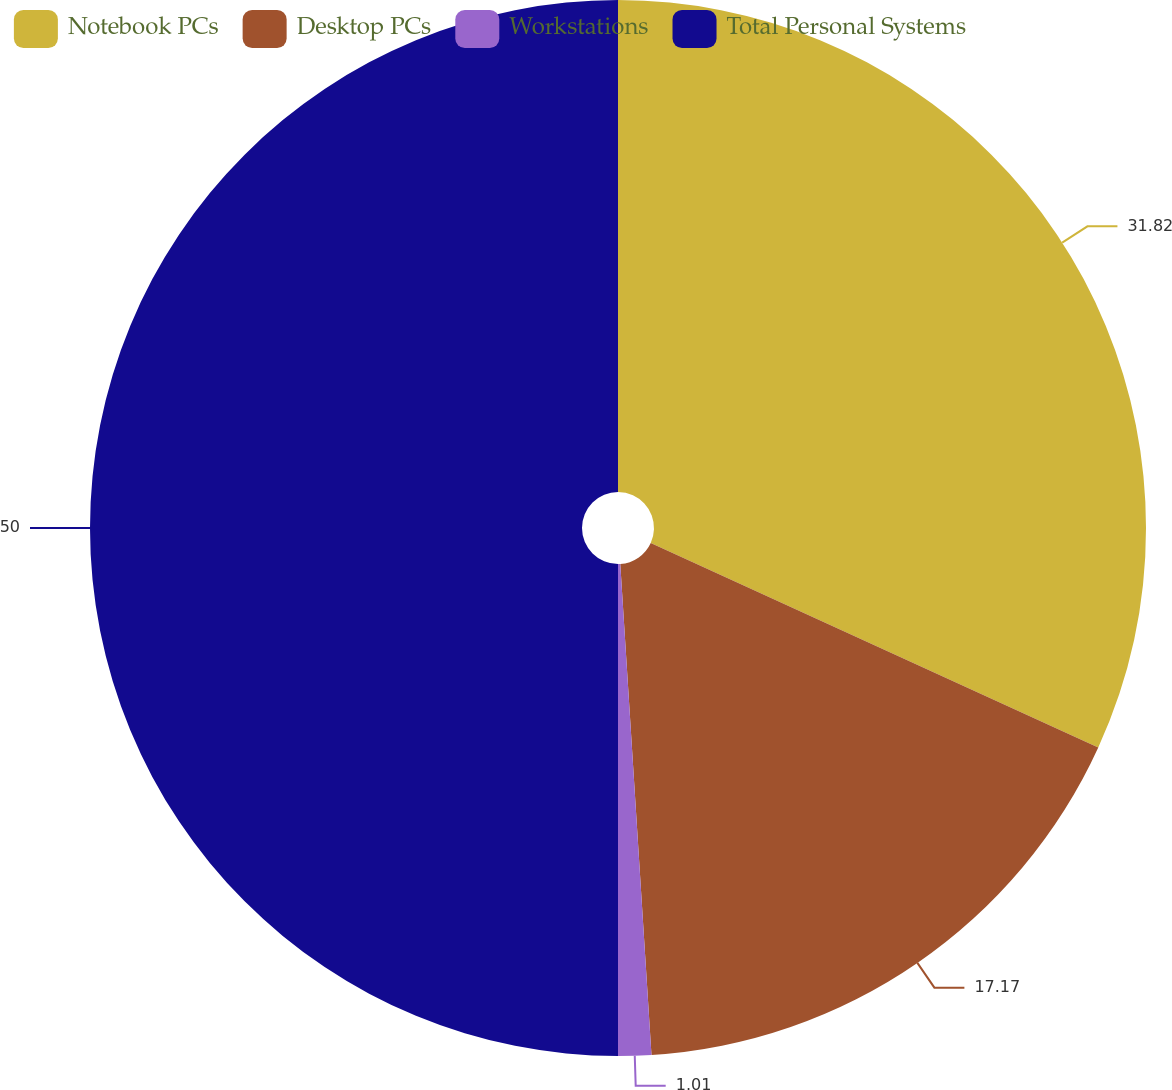Convert chart to OTSL. <chart><loc_0><loc_0><loc_500><loc_500><pie_chart><fcel>Notebook PCs<fcel>Desktop PCs<fcel>Workstations<fcel>Total Personal Systems<nl><fcel>31.82%<fcel>17.17%<fcel>1.01%<fcel>50.0%<nl></chart> 